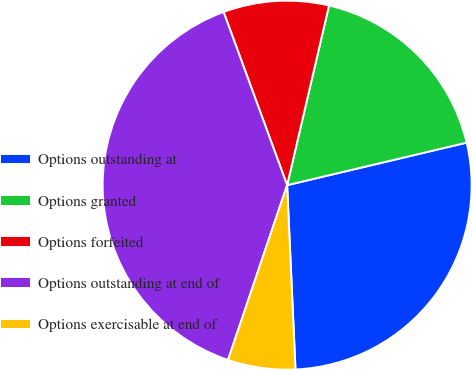Convert chart to OTSL. <chart><loc_0><loc_0><loc_500><loc_500><pie_chart><fcel>Options outstanding at<fcel>Options granted<fcel>Options forfeited<fcel>Options outstanding at end of<fcel>Options exercisable at end of<nl><fcel>27.98%<fcel>17.65%<fcel>9.24%<fcel>39.21%<fcel>5.91%<nl></chart> 